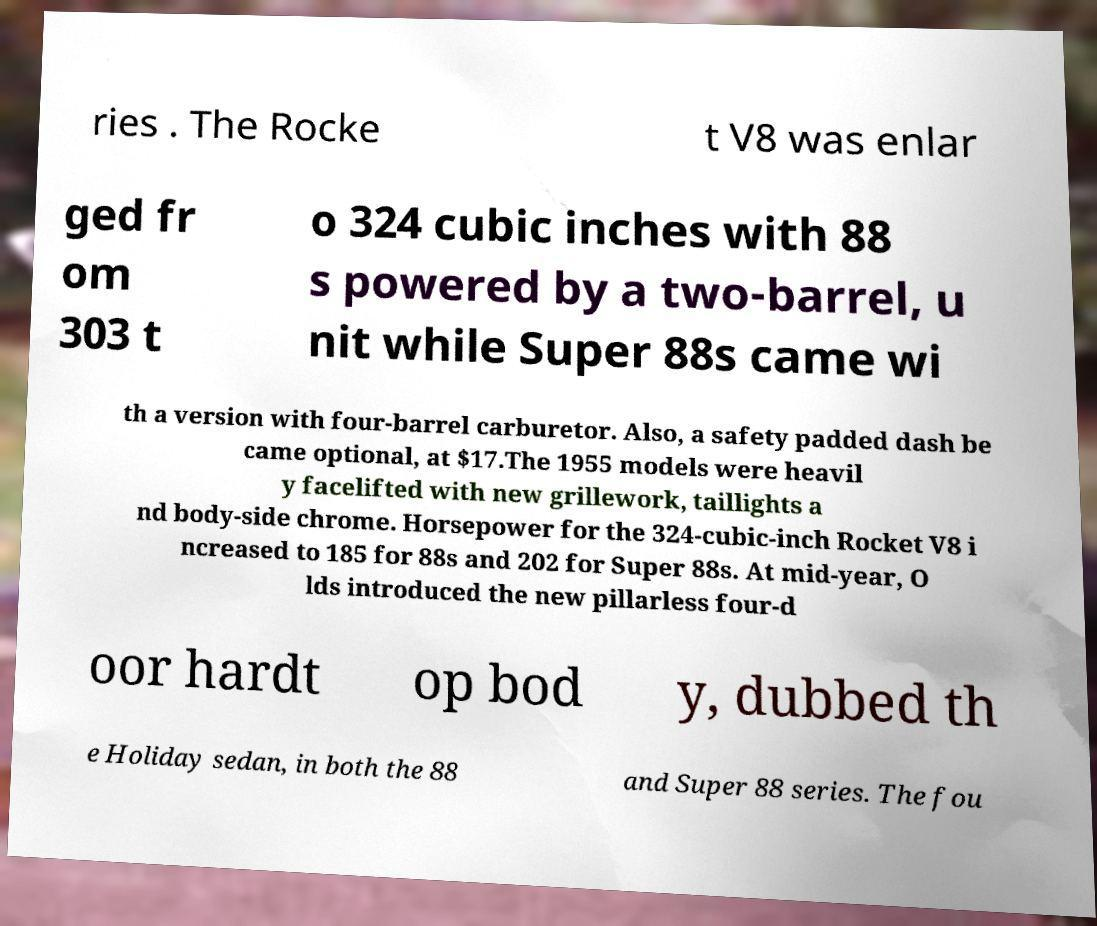Could you assist in decoding the text presented in this image and type it out clearly? ries . The Rocke t V8 was enlar ged fr om 303 t o 324 cubic inches with 88 s powered by a two-barrel, u nit while Super 88s came wi th a version with four-barrel carburetor. Also, a safety padded dash be came optional, at $17.The 1955 models were heavil y facelifted with new grillework, taillights a nd body-side chrome. Horsepower for the 324-cubic-inch Rocket V8 i ncreased to 185 for 88s and 202 for Super 88s. At mid-year, O lds introduced the new pillarless four-d oor hardt op bod y, dubbed th e Holiday sedan, in both the 88 and Super 88 series. The fou 